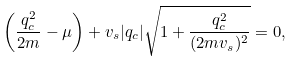Convert formula to latex. <formula><loc_0><loc_0><loc_500><loc_500>\left ( \frac { q _ { c } ^ { 2 } } { 2 m } - \mu \right ) + v _ { s } | q _ { c } | \sqrt { 1 + \frac { q _ { c } ^ { 2 } } { ( 2 m v _ { s } ) ^ { 2 } } } = 0 ,</formula> 